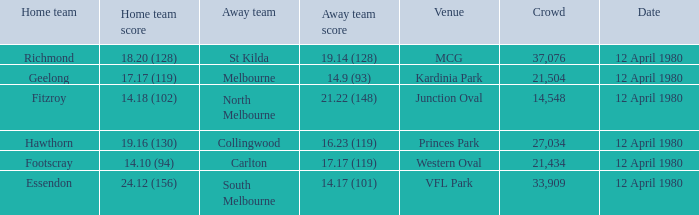Would you be able to parse every entry in this table? {'header': ['Home team', 'Home team score', 'Away team', 'Away team score', 'Venue', 'Crowd', 'Date'], 'rows': [['Richmond', '18.20 (128)', 'St Kilda', '19.14 (128)', 'MCG', '37,076', '12 April 1980'], ['Geelong', '17.17 (119)', 'Melbourne', '14.9 (93)', 'Kardinia Park', '21,504', '12 April 1980'], ['Fitzroy', '14.18 (102)', 'North Melbourne', '21.22 (148)', 'Junction Oval', '14,548', '12 April 1980'], ['Hawthorn', '19.16 (130)', 'Collingwood', '16.23 (119)', 'Princes Park', '27,034', '12 April 1980'], ['Footscray', '14.10 (94)', 'Carlton', '17.17 (119)', 'Western Oval', '21,434', '12 April 1980'], ['Essendon', '24.12 (156)', 'South Melbourne', '14.17 (101)', 'VFL Park', '33,909', '12 April 1980']]} Where did Essendon play as the home team? VFL Park. 